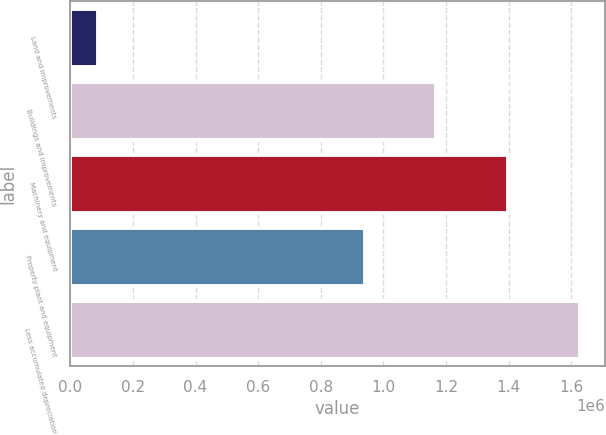Convert chart. <chart><loc_0><loc_0><loc_500><loc_500><bar_chart><fcel>Land and improvements<fcel>Buildings and improvements<fcel>Machinery and equipment<fcel>Property plant and equipment<fcel>Less accumulated depreciation<nl><fcel>87510<fcel>1.16844e+06<fcel>1.39722e+06<fcel>939650<fcel>1.62601e+06<nl></chart> 